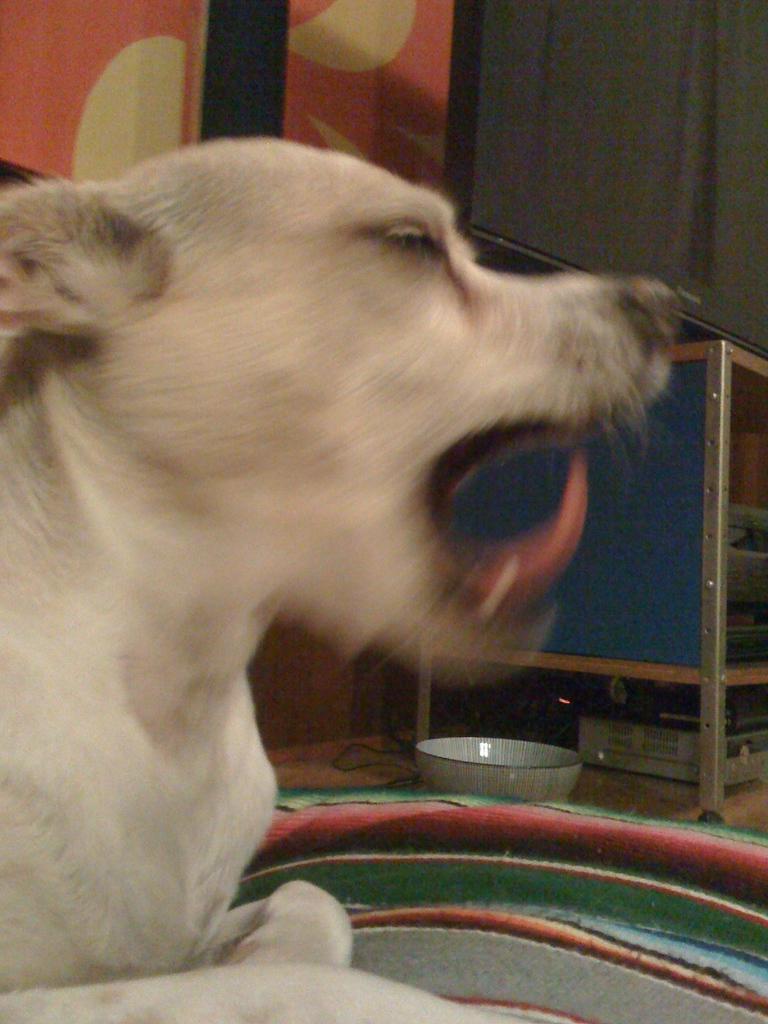In one or two sentences, can you explain what this image depicts? In this image I can see the dog which is in cream color. I can see the bowl, electronic gadget and the television on the table. I can see the red and cream color wall. 